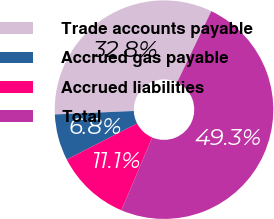Convert chart. <chart><loc_0><loc_0><loc_500><loc_500><pie_chart><fcel>Trade accounts payable<fcel>Accrued gas payable<fcel>Accrued liabilities<fcel>Total<nl><fcel>32.82%<fcel>6.84%<fcel>11.08%<fcel>49.26%<nl></chart> 